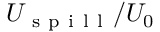<formula> <loc_0><loc_0><loc_500><loc_500>U _ { s p i l l } / U _ { 0 }</formula> 